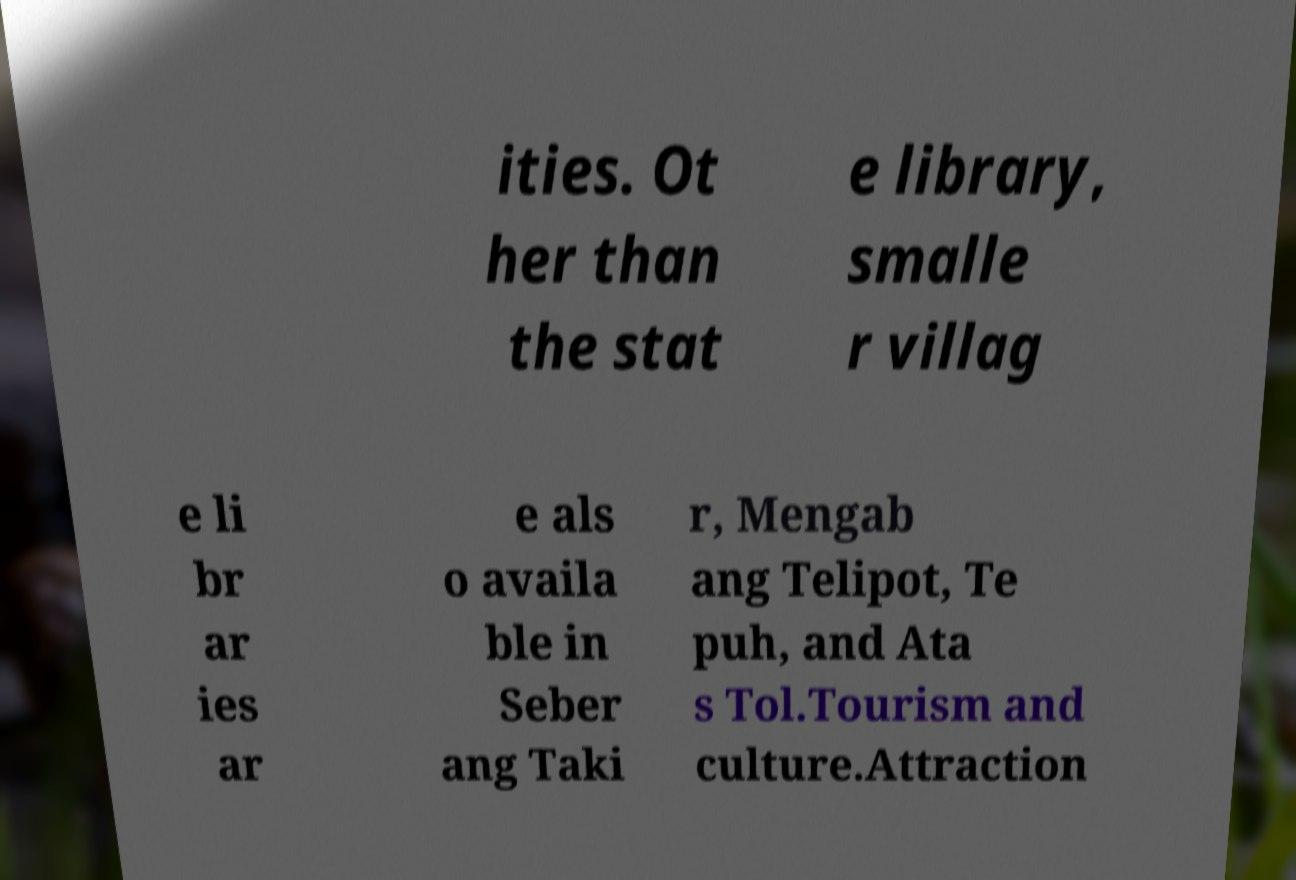Can you read and provide the text displayed in the image?This photo seems to have some interesting text. Can you extract and type it out for me? ities. Ot her than the stat e library, smalle r villag e li br ar ies ar e als o availa ble in Seber ang Taki r, Mengab ang Telipot, Te puh, and Ata s Tol.Tourism and culture.Attraction 